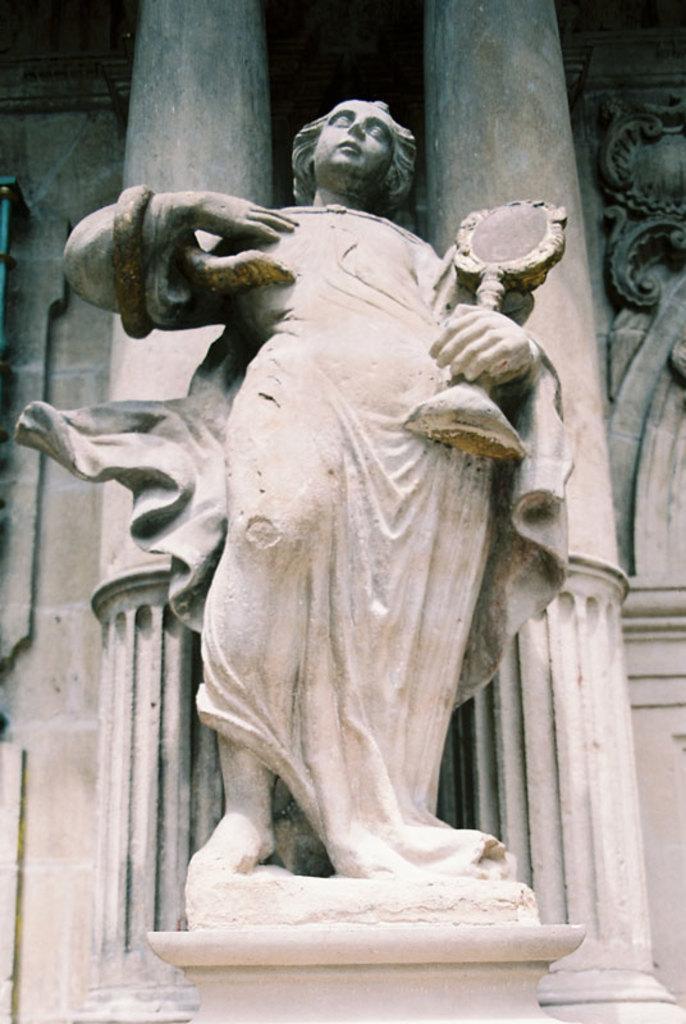Please provide a concise description of this image. Here we can see a statue on a stand. In the background there are pillars and wall. 